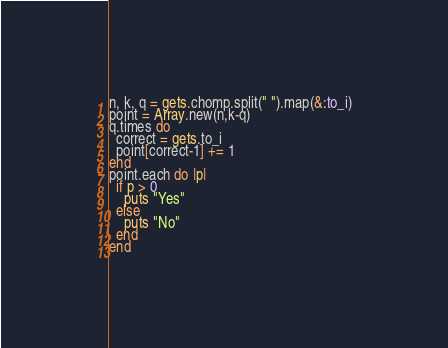Convert code to text. <code><loc_0><loc_0><loc_500><loc_500><_Ruby_>n, k, q = gets.chomp.split(" ").map(&:to_i)
point = Array.new(n,k-q)
q.times do
  correct = gets.to_i
  point[correct-1] += 1
end
point.each do |p|
  if p > 0
    puts "Yes"
  else
    puts "No"
  end
end</code> 